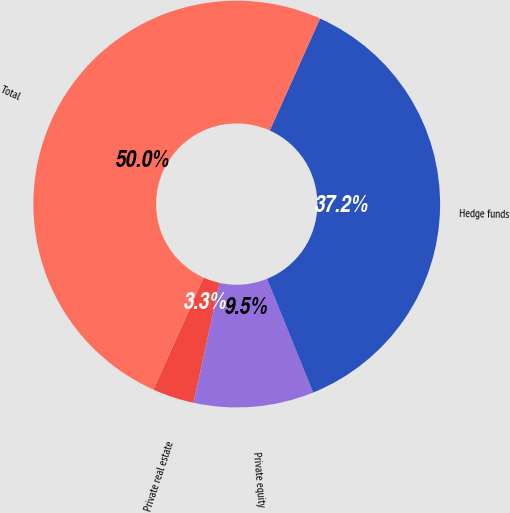Convert chart to OTSL. <chart><loc_0><loc_0><loc_500><loc_500><pie_chart><fcel>Private real estate<fcel>Private equity<fcel>Hedge funds<fcel>Total<nl><fcel>3.31%<fcel>9.54%<fcel>37.15%<fcel>50.0%<nl></chart> 